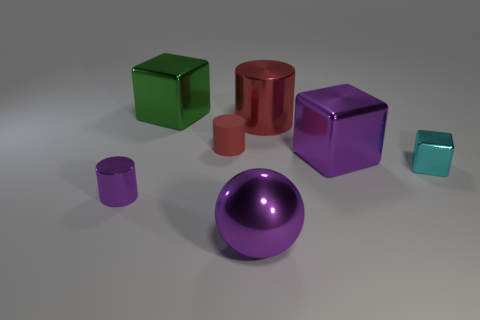What type of material do the objects in the image appear to be made of? The objects in the image seem to be made of a reflective, likely metallic material, indicated by the sharp specular highlights and polished surfaces that give each of them a lustrous finish. How can you tell it's metal and not plastic? The intensity and clarity of the reflections on the surfaces suggest these objects have high specular reflectivity, which is more characteristic of metal than plastic. Plastic tends to diffuse light more and have blunter, less defined highlights. 